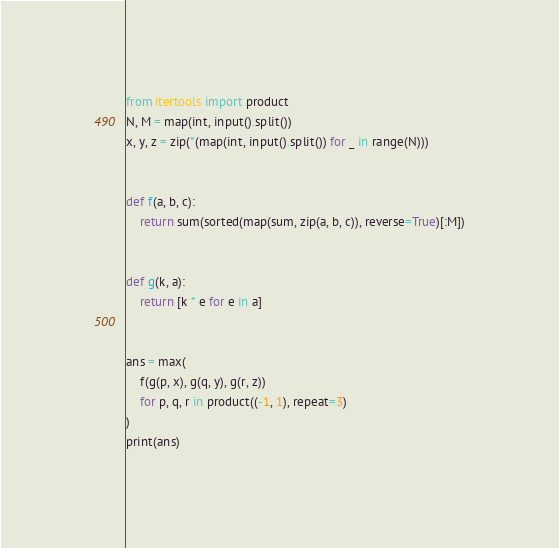<code> <loc_0><loc_0><loc_500><loc_500><_Python_>from itertools import product
N, M = map(int, input().split())
x, y, z = zip(*(map(int, input().split()) for _ in range(N)))


def f(a, b, c):
    return sum(sorted(map(sum, zip(a, b, c)), reverse=True)[:M])


def g(k, a):
    return [k * e for e in a]


ans = max(
    f(g(p, x), g(q, y), g(r, z))
    for p, q, r in product((-1, 1), repeat=3)
)
print(ans)
</code> 